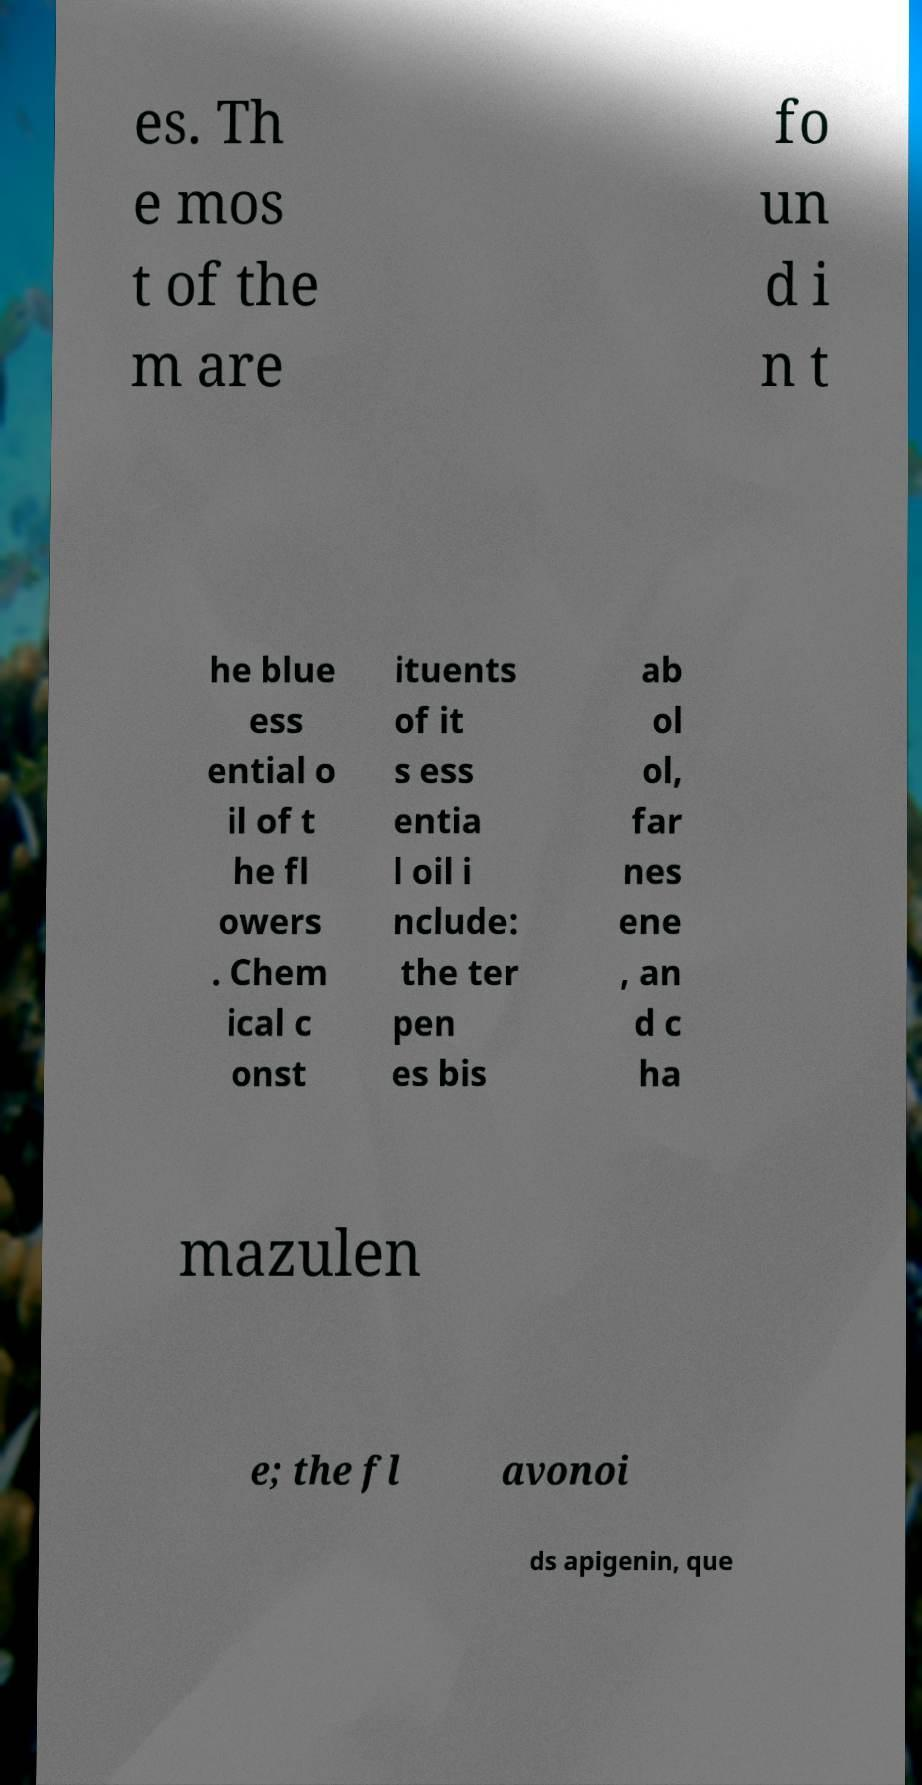I need the written content from this picture converted into text. Can you do that? es. Th e mos t of the m are fo un d i n t he blue ess ential o il of t he fl owers . Chem ical c onst ituents of it s ess entia l oil i nclude: the ter pen es bis ab ol ol, far nes ene , an d c ha mazulen e; the fl avonoi ds apigenin, que 